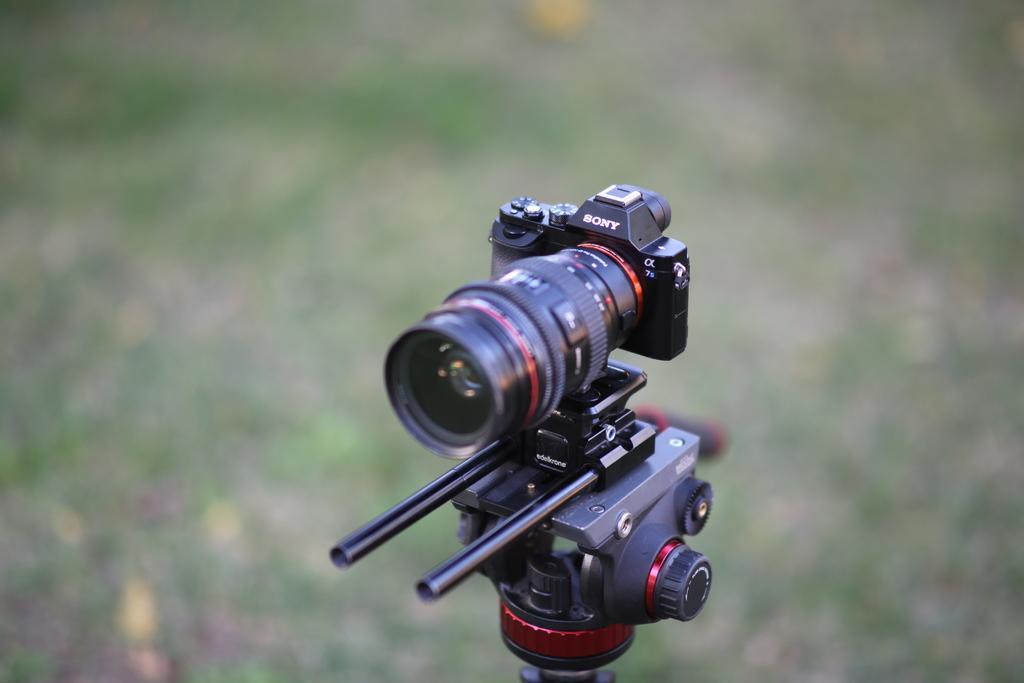Please provide a concise description of this image. In this picture we can see a camera and in the background it is blurry. 